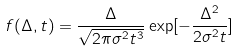<formula> <loc_0><loc_0><loc_500><loc_500>f ( \Delta , t ) = \frac { \Delta } { \sqrt { 2 \pi \sigma ^ { 2 } t ^ { 3 } } } \exp [ - \frac { \Delta ^ { 2 } } { 2 \sigma ^ { 2 } t } ]</formula> 